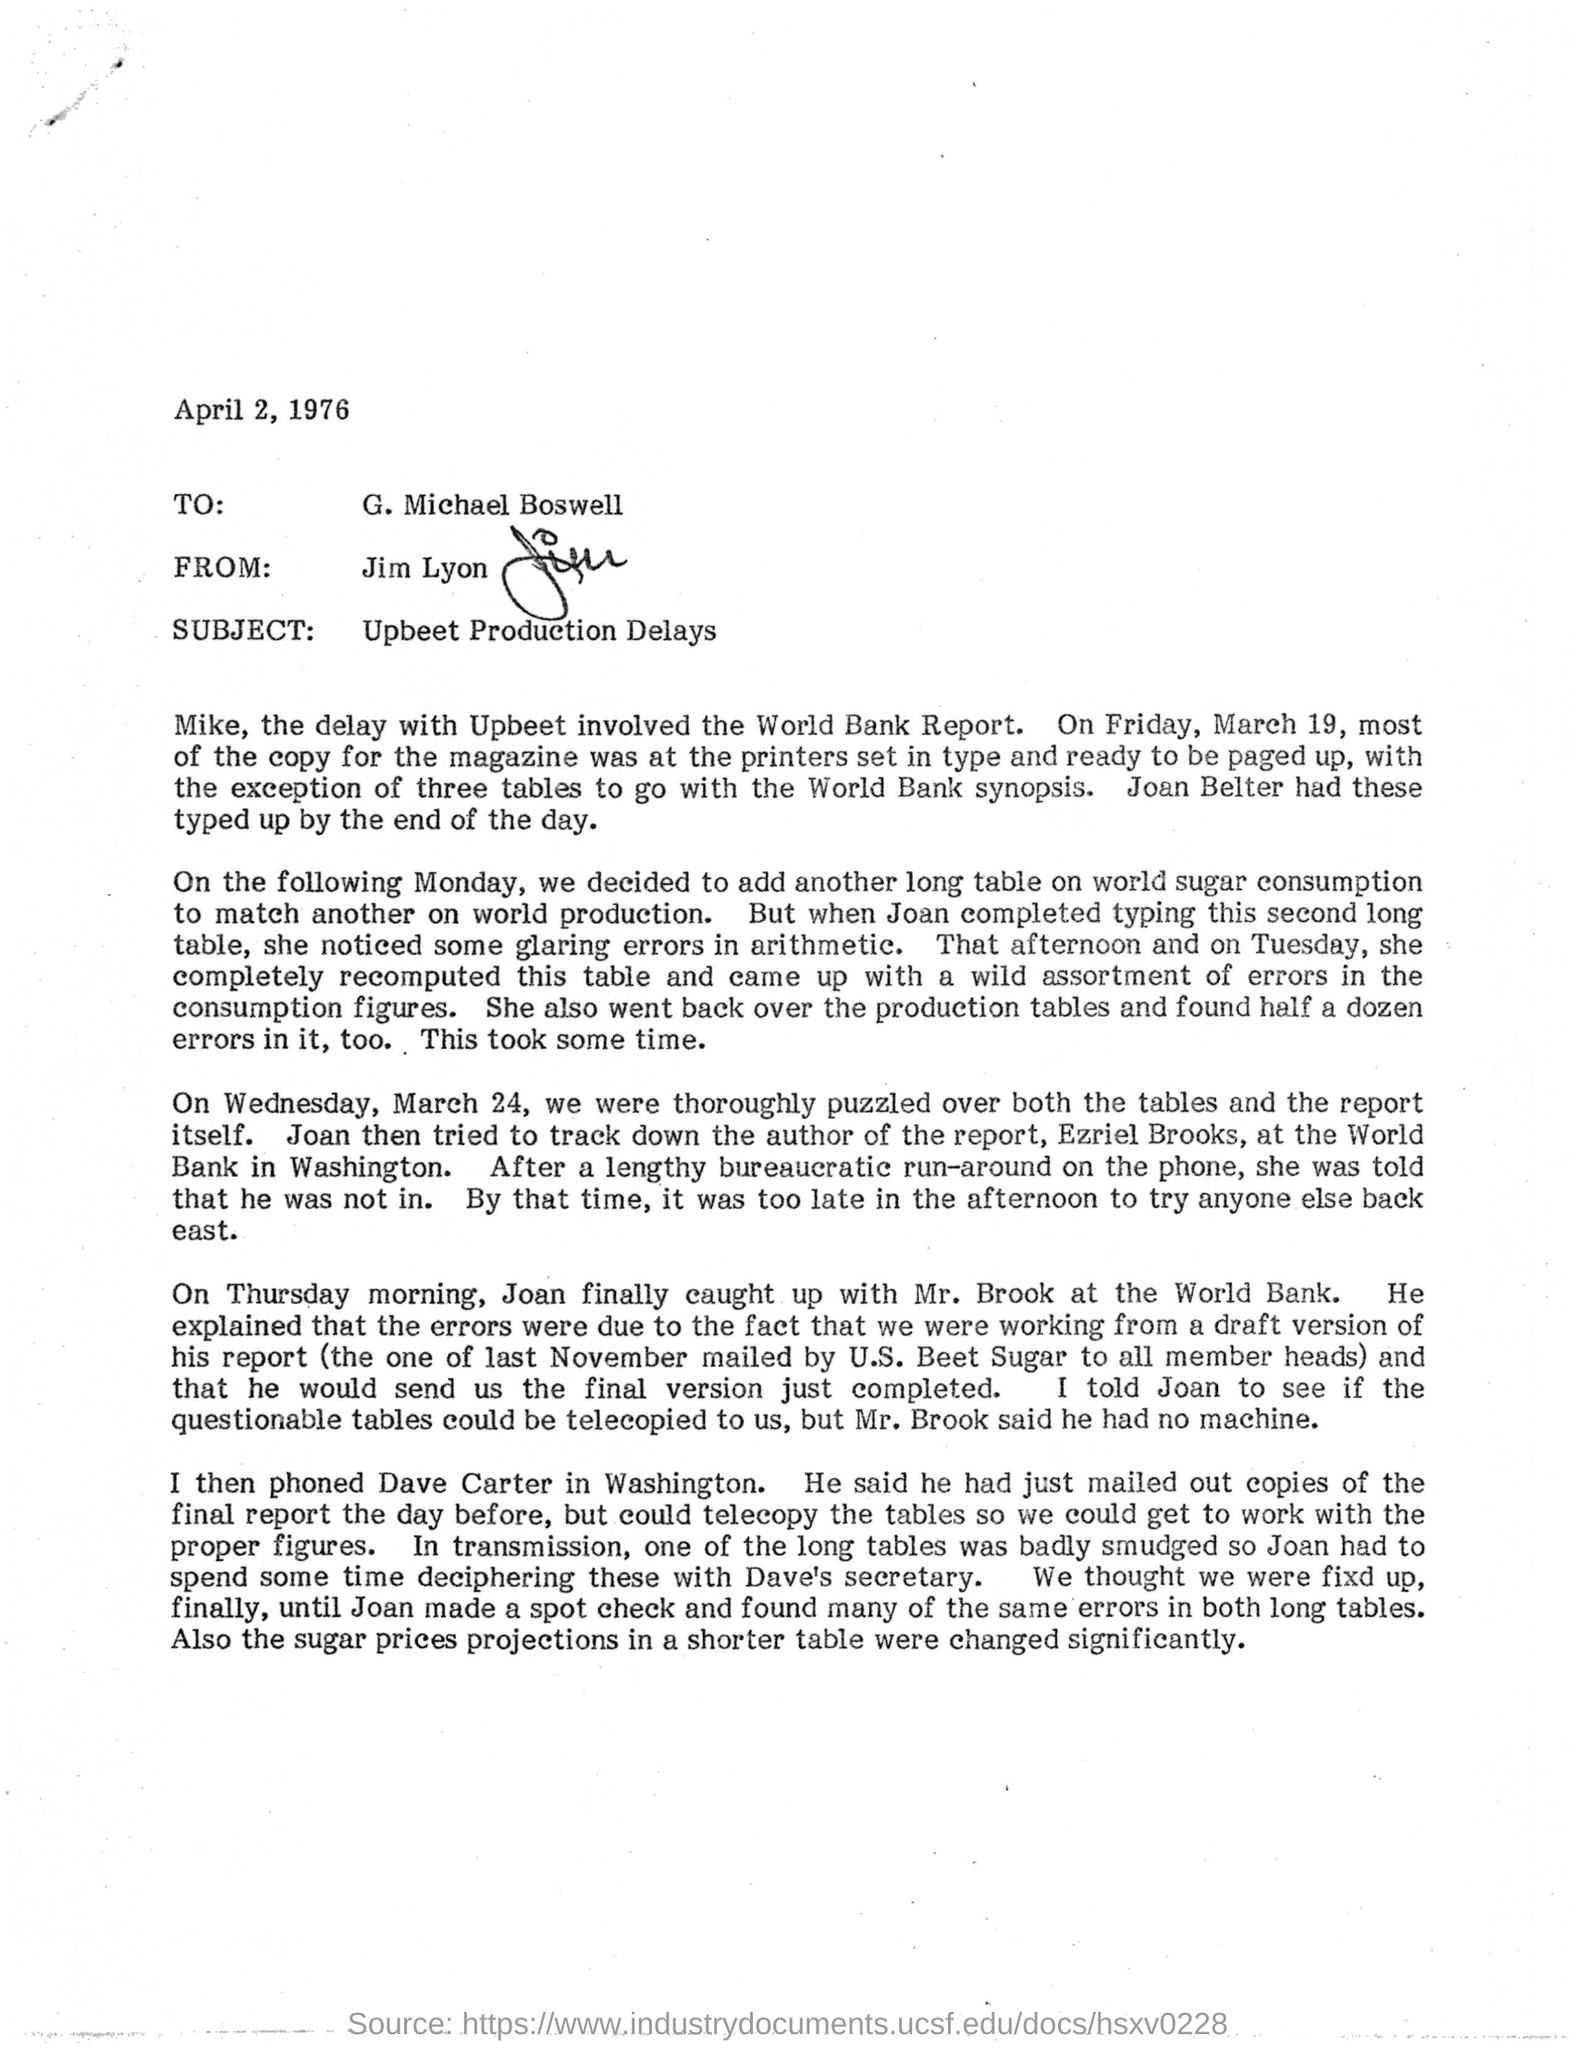What is the subject of the letter?
Ensure brevity in your answer.  Upbeet Production Delays. To Whom is this letter addressed to?
Offer a very short reply. G. Michael Boswell. Who is this letter from?
Ensure brevity in your answer.  Jim Lyon. 